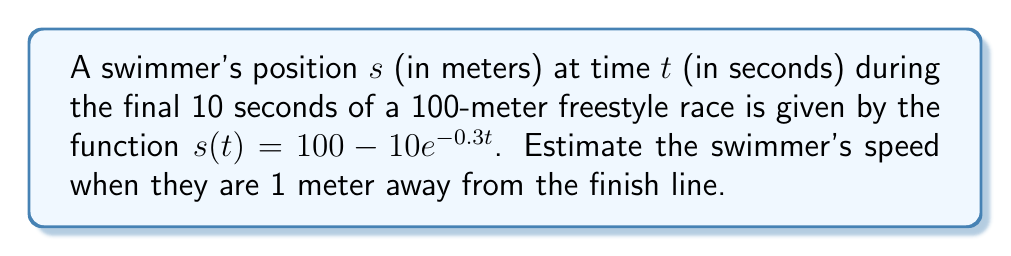Solve this math problem. To solve this problem, we'll follow these steps:

1) First, we need to find the swimmer's speed function by taking the derivative of the position function:
   $$\frac{ds}{dt} = \frac{d}{dt}(100 - 10e^{-0.3t}) = 3e^{-0.3t}$$

2) Now, we need to find at what time t the swimmer is 1 meter away from the finish line. We can do this by solving the equation:
   $$100 - 10e^{-0.3t} = 99$$
   $$-10e^{-0.3t} = -1$$
   $$e^{-0.3t} = 0.1$$
   $$-0.3t = \ln(0.1)$$
   $$t = -\frac{\ln(0.1)}{0.3} \approx 7.67\text{ seconds}$$

3) Now that we know the time, we can plug this back into our speed function:
   $$\text{Speed} = 3e^{-0.3(7.67)} = 3(0.1) = 0.3\text{ m/s}$$

Therefore, when the swimmer is 1 meter away from the finish line, their speed is approximately 0.3 meters per second.
Answer: $0.3\text{ m/s}$ 